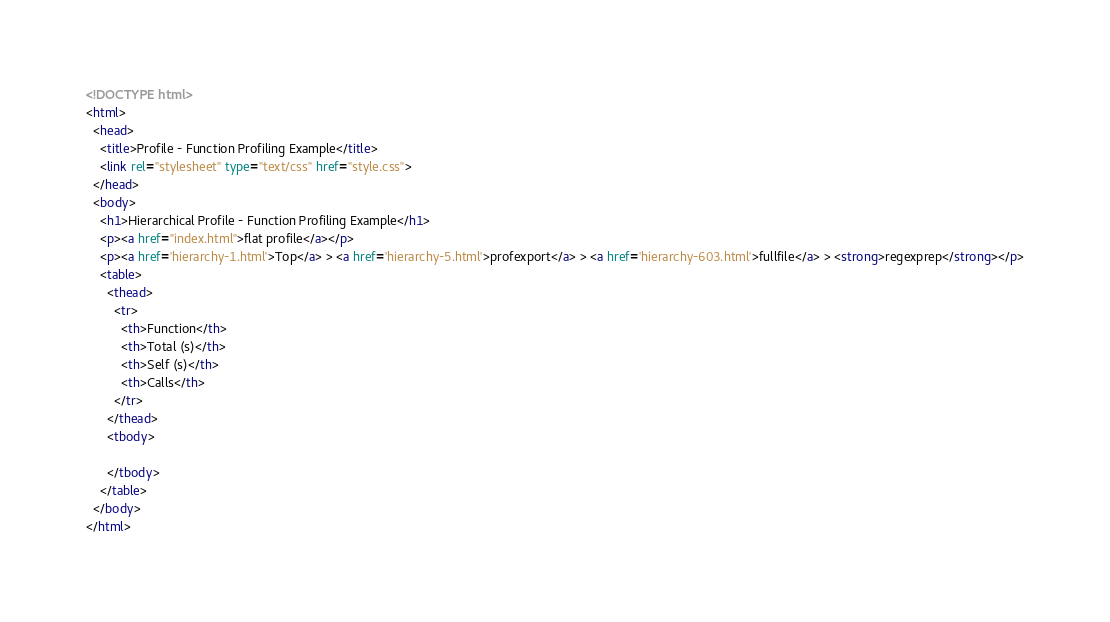<code> <loc_0><loc_0><loc_500><loc_500><_HTML_><!DOCTYPE html>
<html>
  <head>
    <title>Profile - Function Profiling Example</title>
    <link rel="stylesheet" type="text/css" href="style.css">
  </head>
  <body>
    <h1>Hierarchical Profile - Function Profiling Example</h1>
    <p><a href="index.html">flat profile</a></p>
    <p><a href='hierarchy-1.html'>Top</a> > <a href='hierarchy-5.html'>profexport</a> > <a href='hierarchy-603.html'>fullfile</a> > <strong>regexprep</strong></p>
    <table>
      <thead>
        <tr>
          <th>Function</th>
          <th>Total (s)</th>
          <th>Self (s)</th>
          <th>Calls</th>
        </tr>
      </thead>
      <tbody>

      </tbody>
    </table>
  </body>
</html>
</code> 